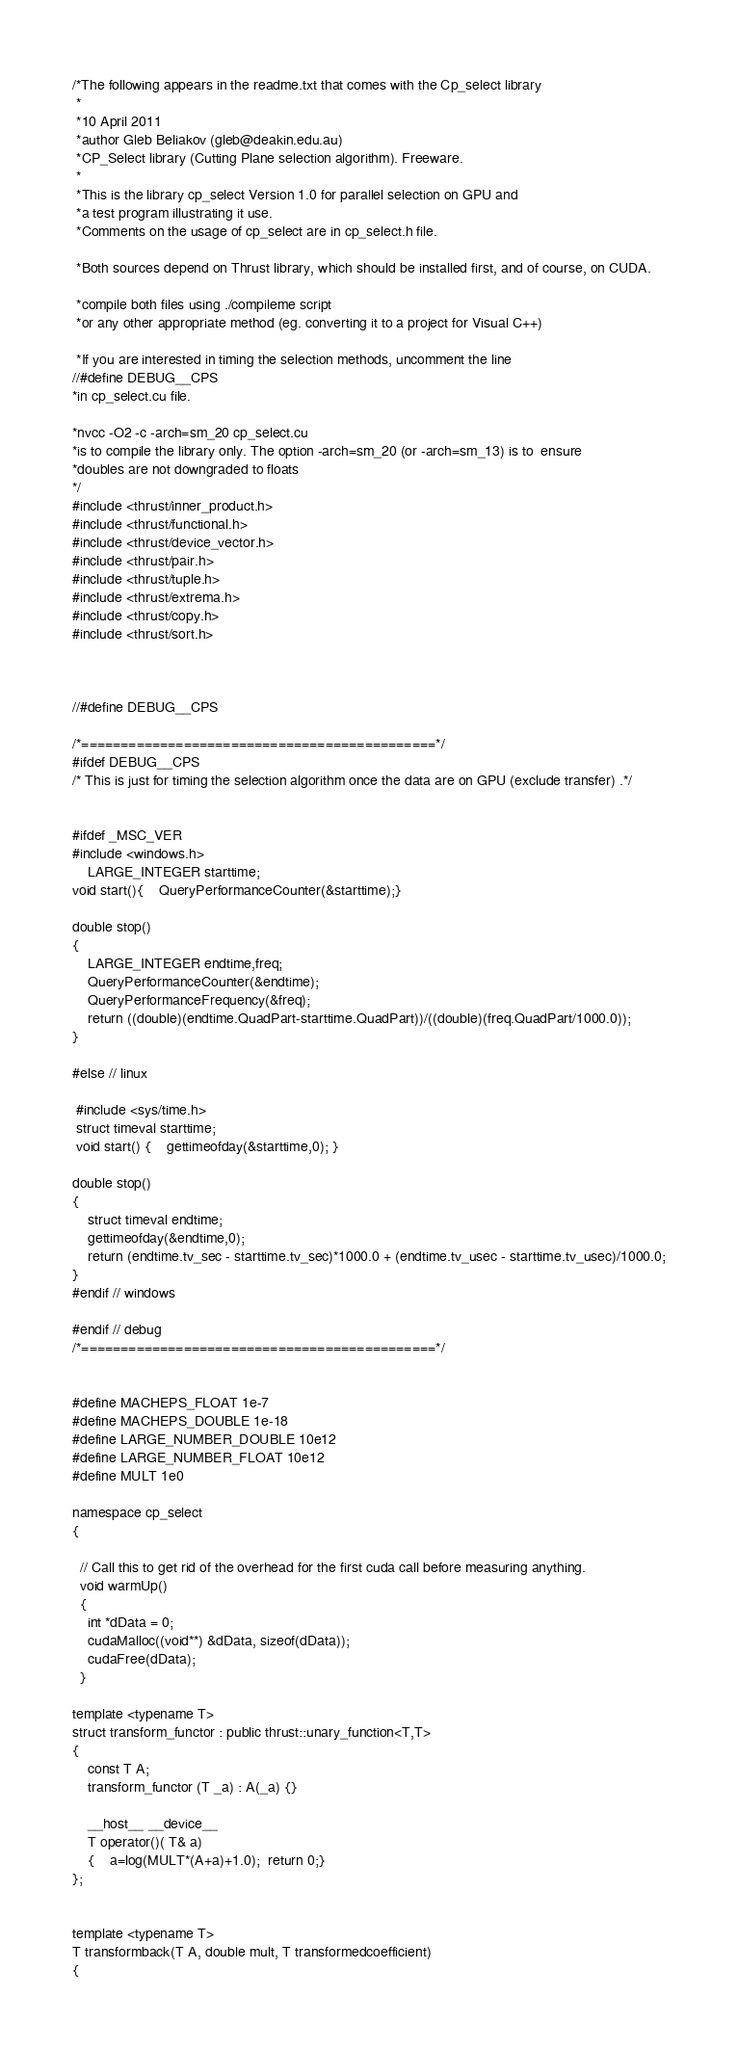Convert code to text. <code><loc_0><loc_0><loc_500><loc_500><_Cuda_>/*The following appears in the readme.txt that comes with the Cp_select library 
 *
 *10 April 2011
 *author Gleb Beliakov (gleb@deakin.edu.au)
 *CP_Select library (Cutting Plane selection algorithm). Freeware.
 *
 *This is the library cp_select Version 1.0 for parallel selection on GPU and 
 *a test program illustrating it use.
 *Comments on the usage of cp_select are in cp_select.h file.

 *Both sources depend on Thrust library, which should be installed first, and of course, on CUDA.

 *compile both files using ./compileme script
 *or any other appropriate method (eg. converting it to a project for Visual C++)

 *If you are interested in timing the selection methods, uncomment the line
//#define DEBUG__CPS 
*in cp_select.cu file.

*nvcc -O2 -c -arch=sm_20 cp_select.cu
*is to compile the library only. The option -arch=sm_20 (or -arch=sm_13) is to  ensure 
*doubles are not downgraded to floats
*/
#include <thrust/inner_product.h>
#include <thrust/functional.h>
#include <thrust/device_vector.h>
#include <thrust/pair.h> 
#include <thrust/tuple.h>
#include <thrust/extrema.h>
#include <thrust/copy.h>
#include <thrust/sort.h>



//#define DEBUG__CPS 

/*=============================================*/
#ifdef DEBUG__CPS
/* This is just for timing the selection algorithm once the data are on GPU (exclude transfer) .*/


#ifdef _MSC_VER
#include <windows.h>
	LARGE_INTEGER starttime;
void start(){ 	QueryPerformanceCounter(&starttime);}

double stop()
{
	LARGE_INTEGER endtime,freq;
	QueryPerformanceCounter(&endtime);
	QueryPerformanceFrequency(&freq);
	return ((double)(endtime.QuadPart-starttime.QuadPart))/((double)(freq.QuadPart/1000.0));
}

#else // linux

 #include <sys/time.h>
 struct timeval starttime;
 void start() {	gettimeofday(&starttime,0); }

double stop()
{
	struct timeval endtime;
	gettimeofday(&endtime,0);
	return (endtime.tv_sec - starttime.tv_sec)*1000.0 + (endtime.tv_usec - starttime.tv_usec)/1000.0;
}
#endif // windows

#endif // debug
/*=============================================*/


#define MACHEPS_FLOAT 1e-7
#define MACHEPS_DOUBLE 1e-18
#define LARGE_NUMBER_DOUBLE 10e12
#define LARGE_NUMBER_FLOAT 10e12
#define MULT 1e0

namespace cp_select
{

  // Call this to get rid of the overhead for the first cuda call before measuring anything.
  void warmUp()
  {
    int *dData = 0;
    cudaMalloc((void**) &dData, sizeof(dData));
    cudaFree(dData); 
  }

template <typename T>
struct transform_functor : public thrust::unary_function<T,T>
{
	const T A;
	transform_functor (T _a) : A(_a) {}

    __host__ __device__
    T operator()( T& a)
    {    a=log(MULT*(A+a)+1.0);  return 0;}
};


template <typename T>
T transformback(T A, double mult, T transformedcoefficient)
{</code> 